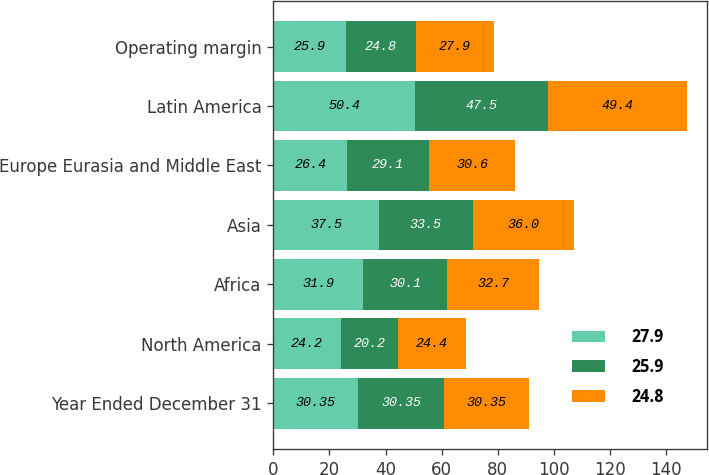Convert chart to OTSL. <chart><loc_0><loc_0><loc_500><loc_500><stacked_bar_chart><ecel><fcel>Year Ended December 31<fcel>North America<fcel>Africa<fcel>Asia<fcel>Europe Eurasia and Middle East<fcel>Latin America<fcel>Operating margin<nl><fcel>27.9<fcel>30.35<fcel>24.2<fcel>31.9<fcel>37.5<fcel>26.4<fcel>50.4<fcel>25.9<nl><fcel>25.9<fcel>30.35<fcel>20.2<fcel>30.1<fcel>33.5<fcel>29.1<fcel>47.5<fcel>24.8<nl><fcel>24.8<fcel>30.35<fcel>24.4<fcel>32.7<fcel>36<fcel>30.6<fcel>49.4<fcel>27.9<nl></chart> 